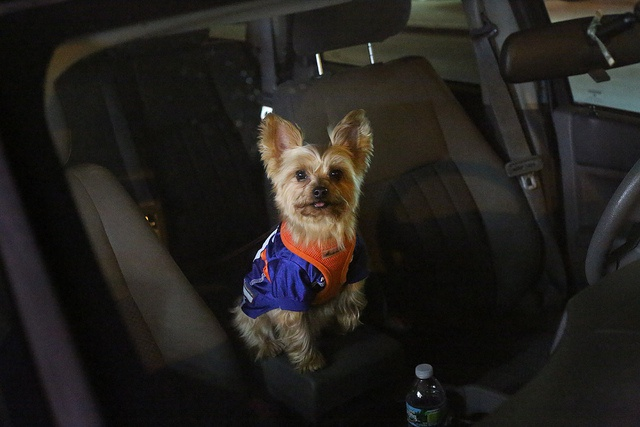Describe the objects in this image and their specific colors. I can see chair in black tones, dog in black, gray, and maroon tones, and bottle in black, gray, blue, and darkblue tones in this image. 